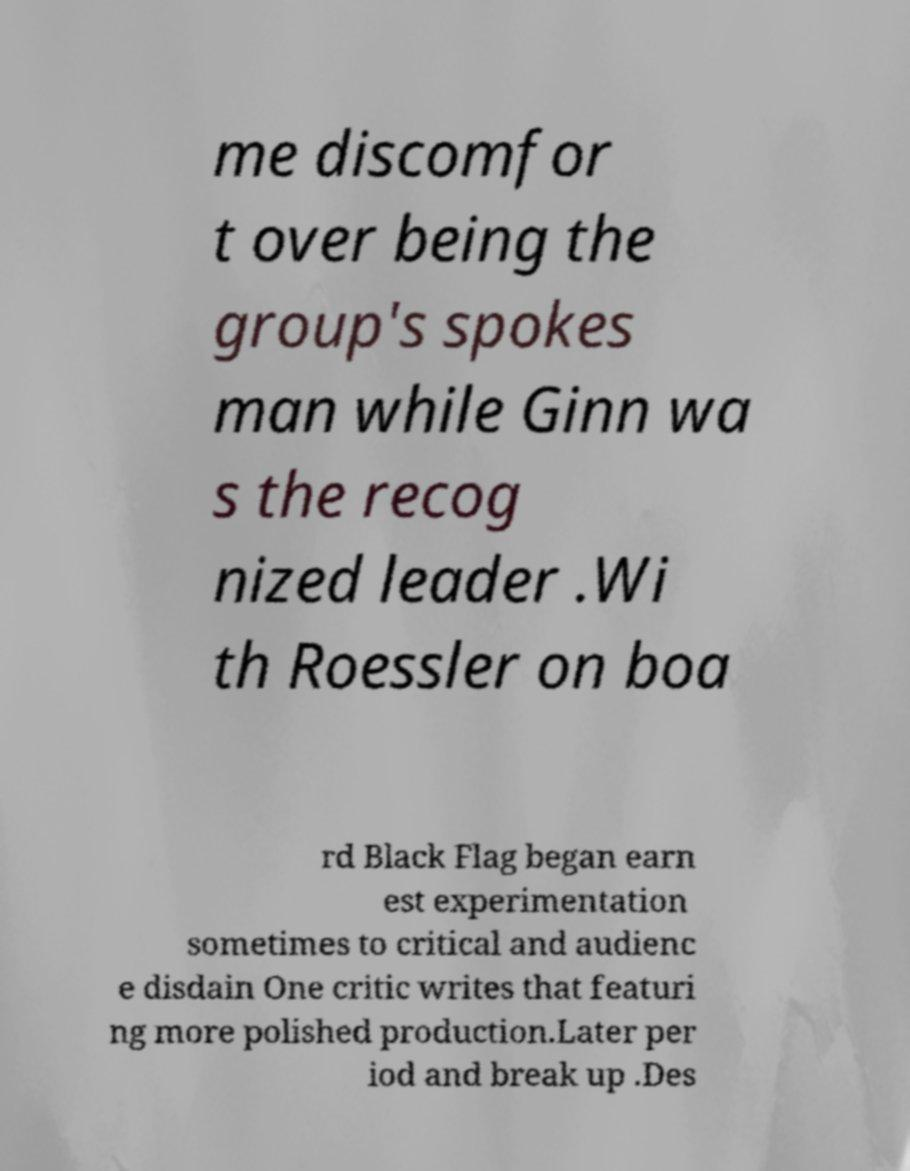Please identify and transcribe the text found in this image. me discomfor t over being the group's spokes man while Ginn wa s the recog nized leader .Wi th Roessler on boa rd Black Flag began earn est experimentation sometimes to critical and audienc e disdain One critic writes that featuri ng more polished production.Later per iod and break up .Des 